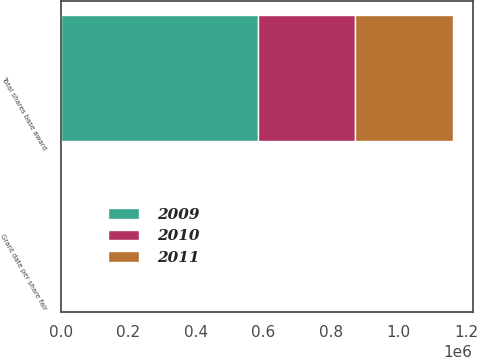<chart> <loc_0><loc_0><loc_500><loc_500><stacked_bar_chart><ecel><fcel>Total shares base award<fcel>Grant date per share fair<nl><fcel>2010<fcel>287014<fcel>25.41<nl><fcel>2011<fcel>289888<fcel>21.96<nl><fcel>2009<fcel>584650<fcel>15.76<nl></chart> 